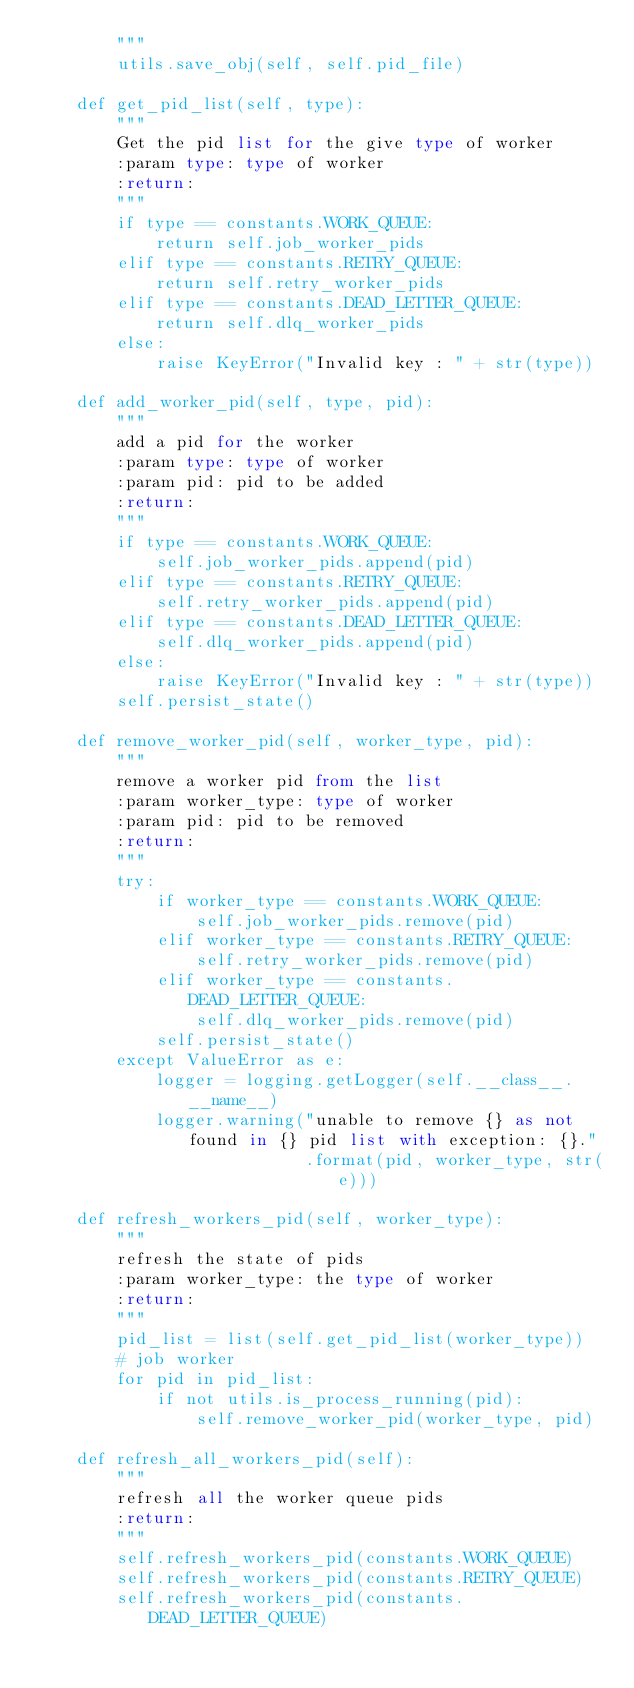Convert code to text. <code><loc_0><loc_0><loc_500><loc_500><_Python_>        """
        utils.save_obj(self, self.pid_file)

    def get_pid_list(self, type):
        """
        Get the pid list for the give type of worker
        :param type: type of worker
        :return: 
        """
        if type == constants.WORK_QUEUE:
            return self.job_worker_pids
        elif type == constants.RETRY_QUEUE:
            return self.retry_worker_pids
        elif type == constants.DEAD_LETTER_QUEUE:
            return self.dlq_worker_pids
        else:
            raise KeyError("Invalid key : " + str(type))

    def add_worker_pid(self, type, pid):
        """
        add a pid for the worker
        :param type: type of worker
        :param pid: pid to be added
        :return: 
        """
        if type == constants.WORK_QUEUE:
            self.job_worker_pids.append(pid)
        elif type == constants.RETRY_QUEUE:
            self.retry_worker_pids.append(pid)
        elif type == constants.DEAD_LETTER_QUEUE:
            self.dlq_worker_pids.append(pid)
        else:
            raise KeyError("Invalid key : " + str(type))
        self.persist_state()

    def remove_worker_pid(self, worker_type, pid):
        """
        remove a worker pid from the list
        :param worker_type: type of worker
        :param pid: pid to be removed
        :return: 
        """
        try:
            if worker_type == constants.WORK_QUEUE:
                self.job_worker_pids.remove(pid)
            elif worker_type == constants.RETRY_QUEUE:
                self.retry_worker_pids.remove(pid)
            elif worker_type == constants.DEAD_LETTER_QUEUE:
                self.dlq_worker_pids.remove(pid)
            self.persist_state()
        except ValueError as e:
            logger = logging.getLogger(self.__class__.__name__)
            logger.warning("unable to remove {} as not found in {} pid list with exception: {}."
                           .format(pid, worker_type, str(e)))

    def refresh_workers_pid(self, worker_type):
        """
        refresh the state of pids
        :param worker_type: the type of worker
        :return: 
        """
        pid_list = list(self.get_pid_list(worker_type))
        # job worker
        for pid in pid_list:
            if not utils.is_process_running(pid):
                self.remove_worker_pid(worker_type, pid)

    def refresh_all_workers_pid(self):
        """
        refresh all the worker queue pids
        :return: 
        """
        self.refresh_workers_pid(constants.WORK_QUEUE)
        self.refresh_workers_pid(constants.RETRY_QUEUE)
        self.refresh_workers_pid(constants.DEAD_LETTER_QUEUE)
</code> 